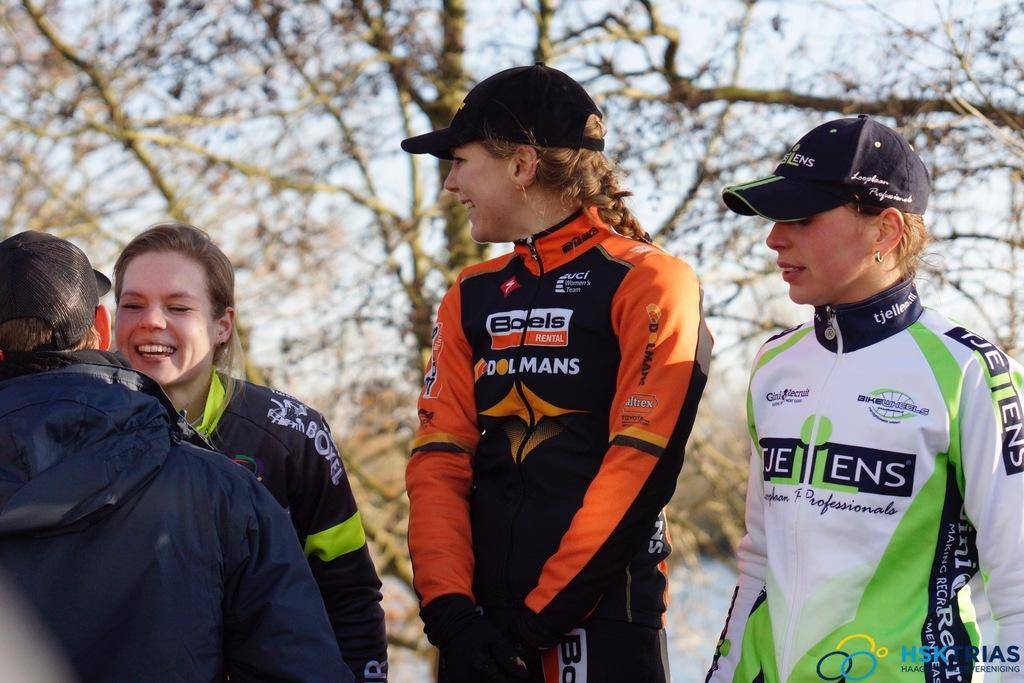In one or two sentences, can you explain what this image depicts? In this image there are group of people standing and smiling, and some of them are wearing caps. In the background there are trees and sky. 